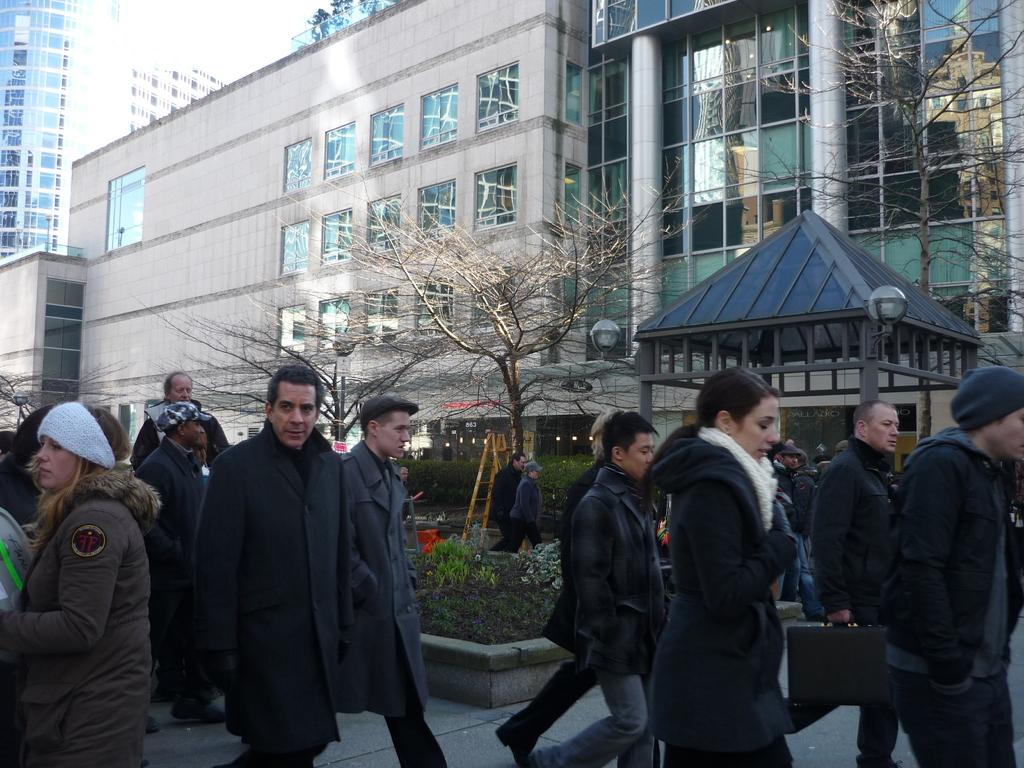What type of structures can be seen in the image? There are buildings in the image. What are the people in the image doing? There are people walking in the image. What type of vegetation is present in the image? There is a tree in the image. What is visible at the top of the image? The sky is visible at the top of the image. What flavor of ice cream is the spy eating while walking in the image? There is no ice cream or spy present in the image. What part of the tree is visible in the image? The entire tree is not visible in the image, but a portion of it is present. 